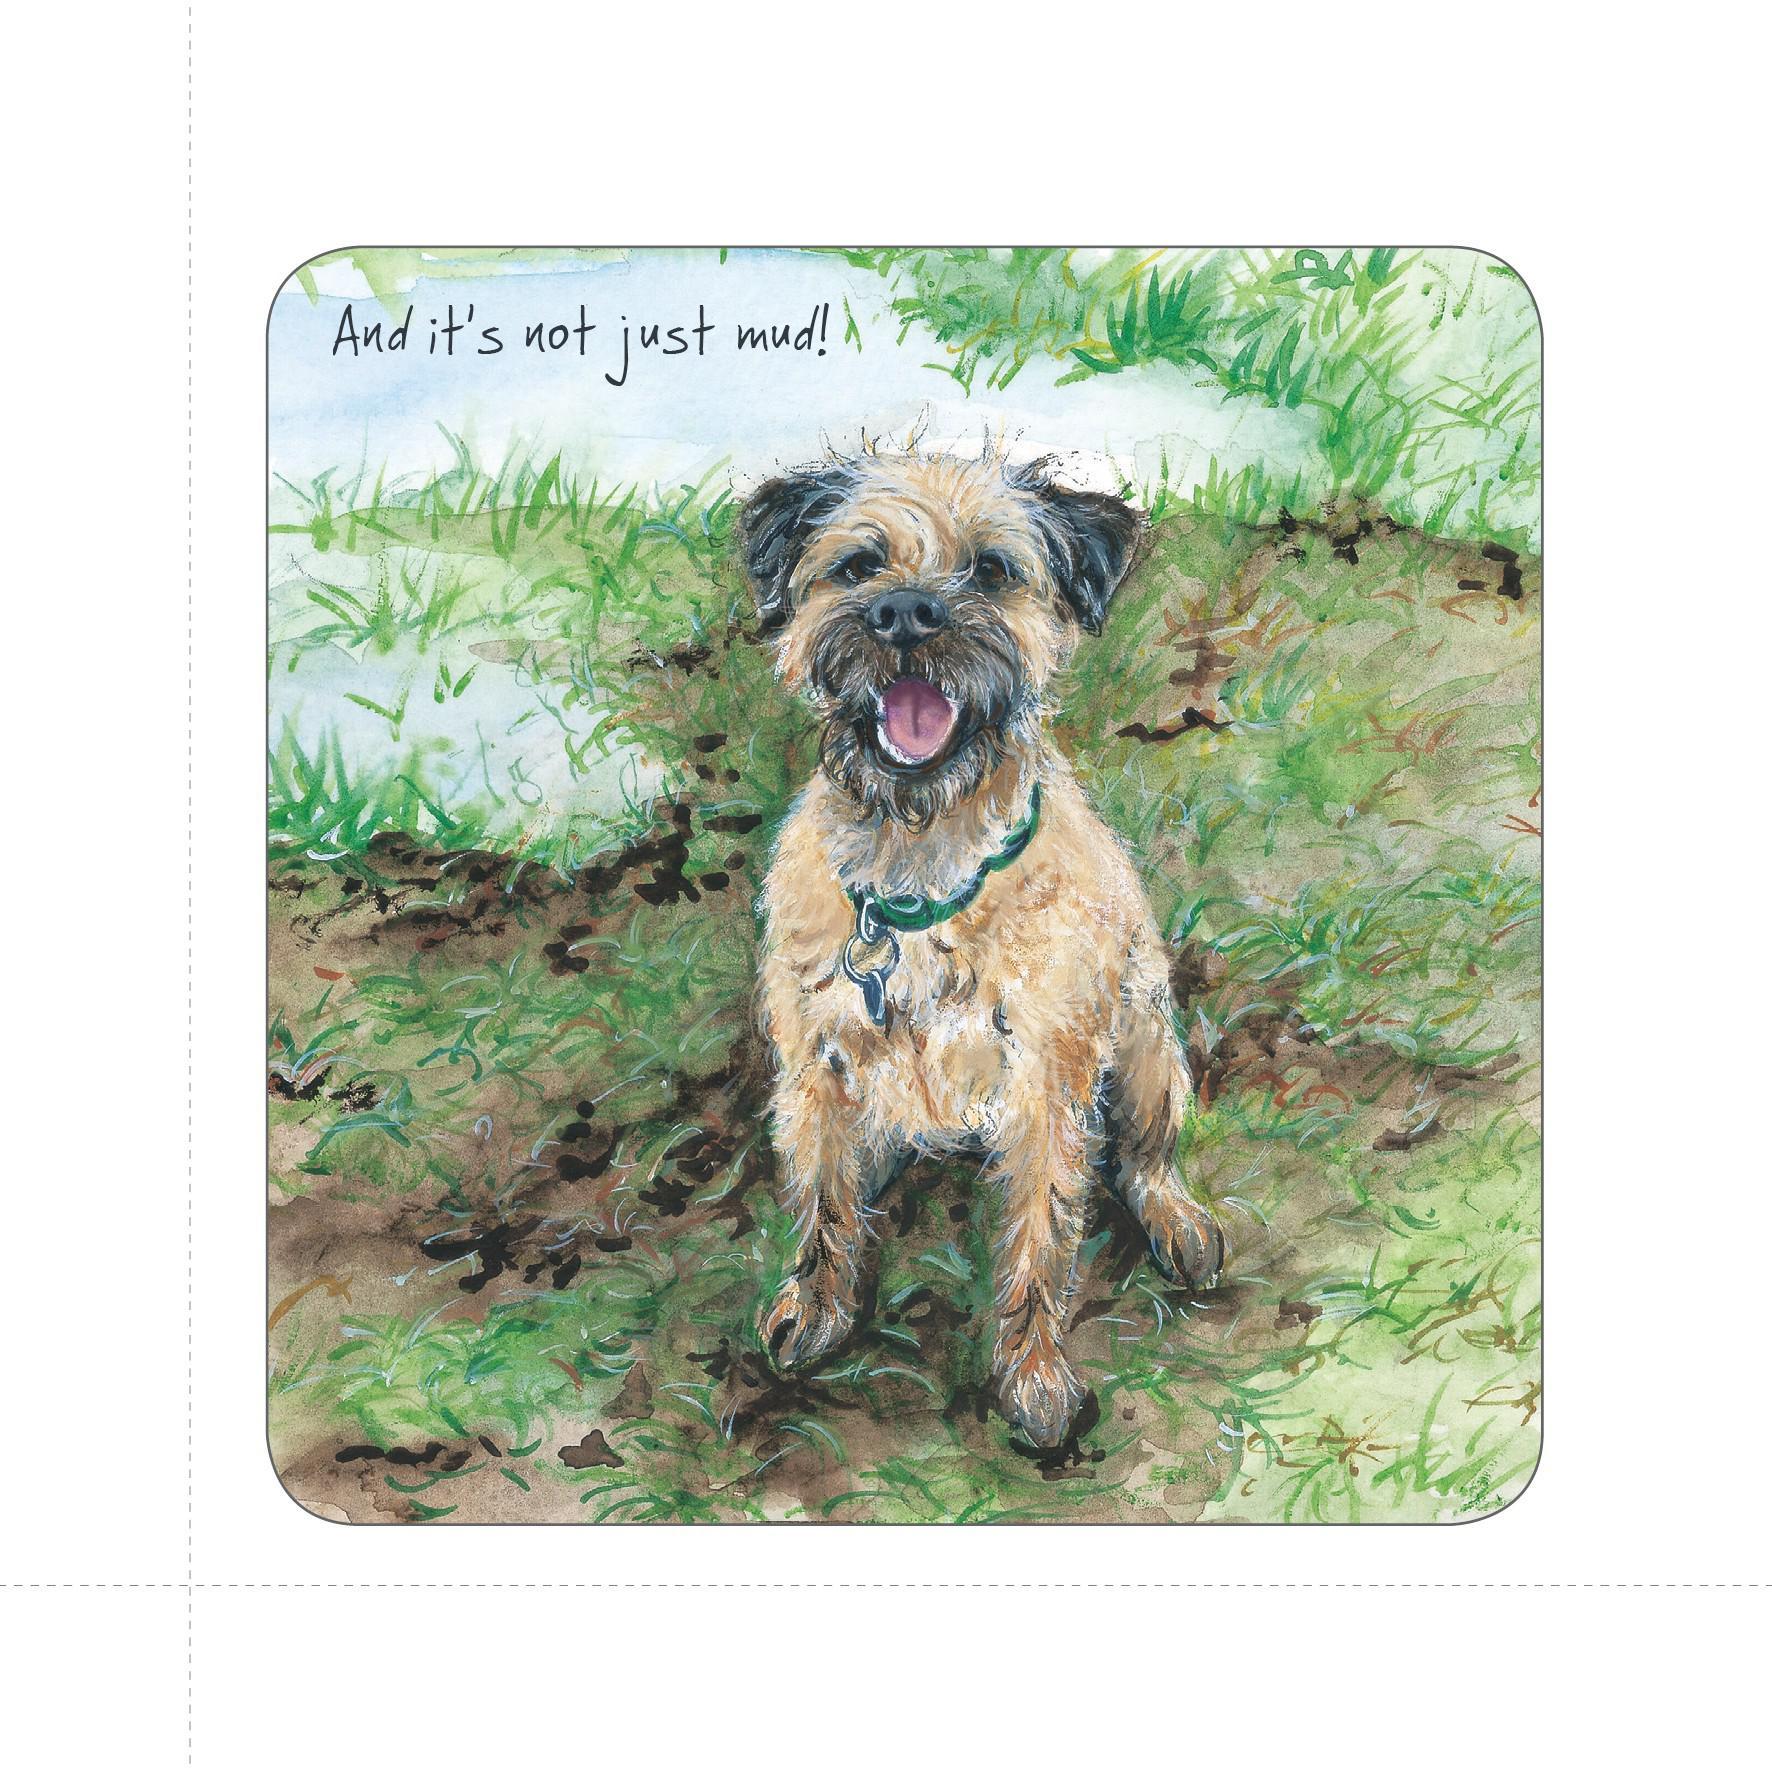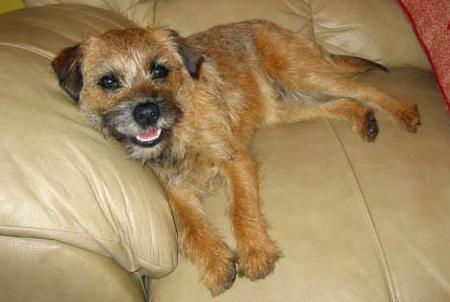The first image is the image on the left, the second image is the image on the right. Given the left and right images, does the statement "The left and right image contains the same number of dogs with at least one standing." hold true? Answer yes or no. No. The first image is the image on the left, the second image is the image on the right. For the images displayed, is the sentence "The right image features one dog reclining on something soft and looking at the camera, and the left image shows a dog in an upright pose." factually correct? Answer yes or no. Yes. 